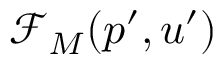Convert formula to latex. <formula><loc_0><loc_0><loc_500><loc_500>\mathcal { F } _ { M } ( p ^ { \prime } , u ^ { \prime } )</formula> 